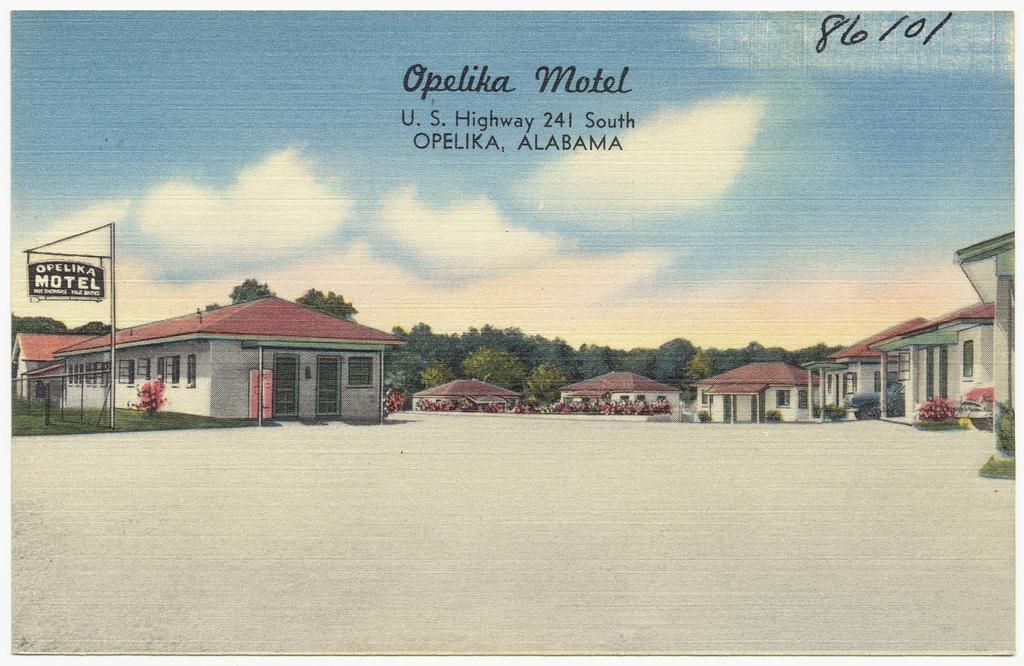Please provide a concise description of this image. In this picture we can see a poster, in this poster we can see ground, houses, plants, grass and board on pole. In the background of the image we can see trees and sky. At the top of the image we can see text. 